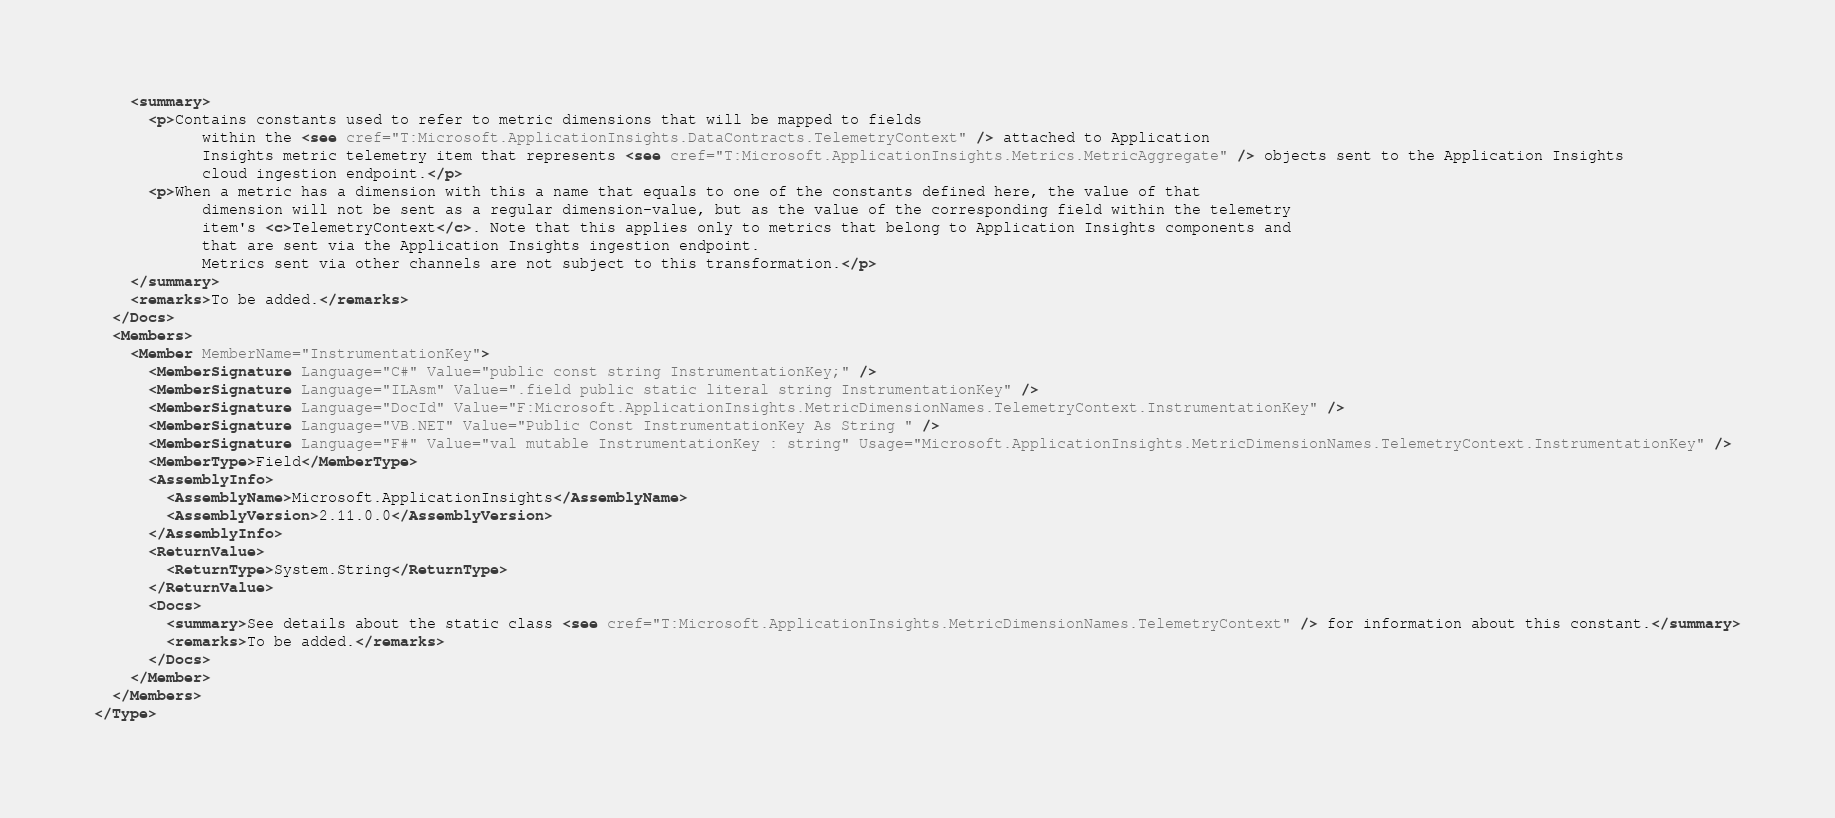<code> <loc_0><loc_0><loc_500><loc_500><_XML_>    <summary>
      <p>Contains constants used to refer to metric dimensions that will be mapped to fields
            within the <see cref="T:Microsoft.ApplicationInsights.DataContracts.TelemetryContext" /> attached to Application
            Insights metric telemetry item that represents <see cref="T:Microsoft.ApplicationInsights.Metrics.MetricAggregate" /> objects sent to the Application Insights
            cloud ingestion endpoint.</p>
      <p>When a metric has a dimension with this a name that equals to one of the constants defined here, the value of that
            dimension will not be sent as a regular dimension-value, but as the value of the corresponding field within the telemetry
            item's <c>TelemetryContext</c>. Note that this applies only to metrics that belong to Application Insights components and
            that are sent via the Application Insights ingestion endpoint.
            Metrics sent via other channels are not subject to this transformation.</p>
    </summary>
    <remarks>To be added.</remarks>
  </Docs>
  <Members>
    <Member MemberName="InstrumentationKey">
      <MemberSignature Language="C#" Value="public const string InstrumentationKey;" />
      <MemberSignature Language="ILAsm" Value=".field public static literal string InstrumentationKey" />
      <MemberSignature Language="DocId" Value="F:Microsoft.ApplicationInsights.MetricDimensionNames.TelemetryContext.InstrumentationKey" />
      <MemberSignature Language="VB.NET" Value="Public Const InstrumentationKey As String " />
      <MemberSignature Language="F#" Value="val mutable InstrumentationKey : string" Usage="Microsoft.ApplicationInsights.MetricDimensionNames.TelemetryContext.InstrumentationKey" />
      <MemberType>Field</MemberType>
      <AssemblyInfo>
        <AssemblyName>Microsoft.ApplicationInsights</AssemblyName>
        <AssemblyVersion>2.11.0.0</AssemblyVersion>
      </AssemblyInfo>
      <ReturnValue>
        <ReturnType>System.String</ReturnType>
      </ReturnValue>
      <Docs>
        <summary>See details about the static class <see cref="T:Microsoft.ApplicationInsights.MetricDimensionNames.TelemetryContext" /> for information about this constant.</summary>
        <remarks>To be added.</remarks>
      </Docs>
    </Member>
  </Members>
</Type>
</code> 